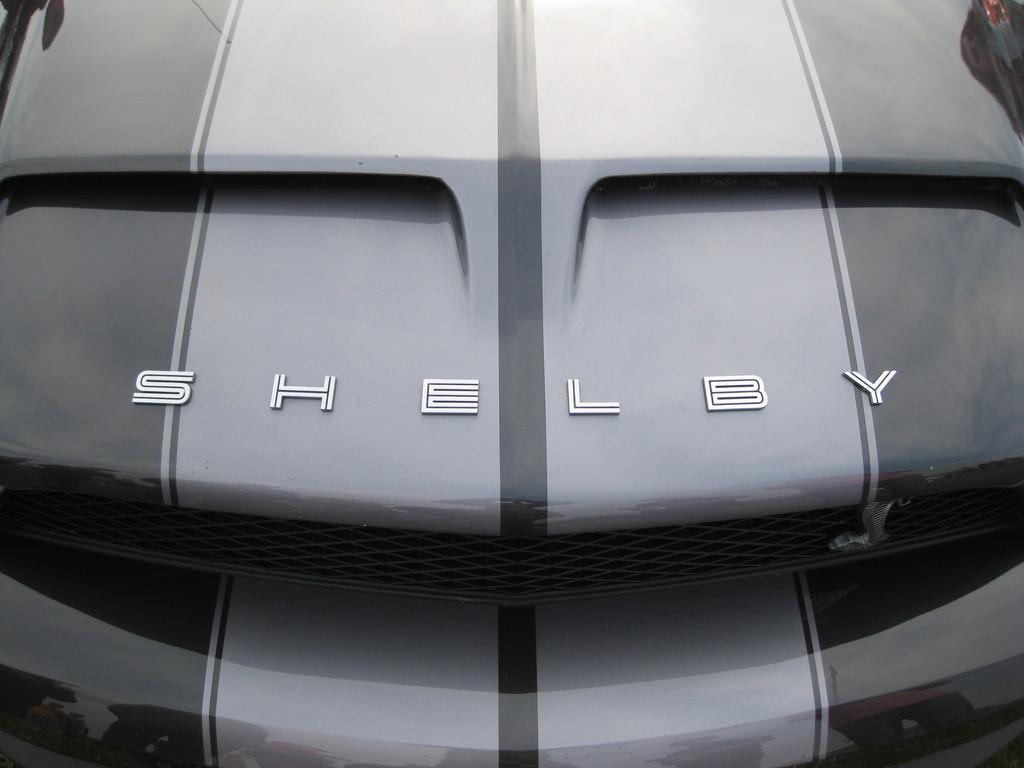How would you summarize this image in a sentence or two? In this picture we can see a vehicle with some text on it. 